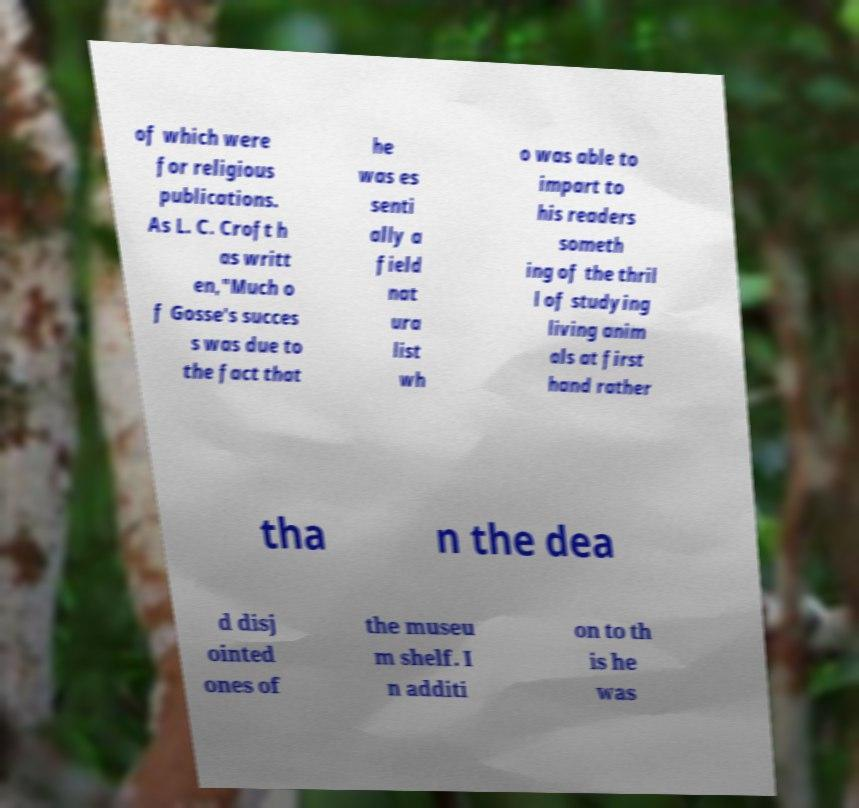Could you assist in decoding the text presented in this image and type it out clearly? of which were for religious publications. As L. C. Croft h as writt en,"Much o f Gosse's succes s was due to the fact that he was es senti ally a field nat ura list wh o was able to impart to his readers someth ing of the thril l of studying living anim als at first hand rather tha n the dea d disj ointed ones of the museu m shelf. I n additi on to th is he was 